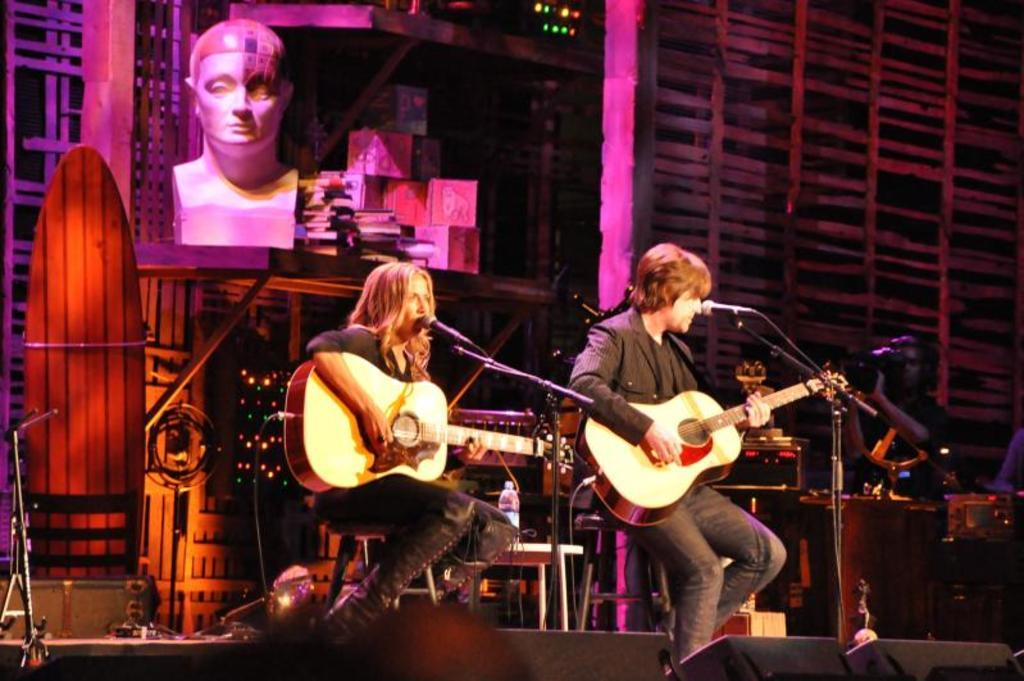How many people are present in the image? There are two people sitting in the image. What are the two people doing? The two people are playing guitar and singing. What object is in front of them? There is a microphone in front of them. Can you describe the person in the background? There is a person holding a video camera in the background. What type of deer can be seen in the image? There are no deer present in the image. Can you tell me what kind of bottle the person holding the video camera is drinking from? There is no bottle visible in the image. 